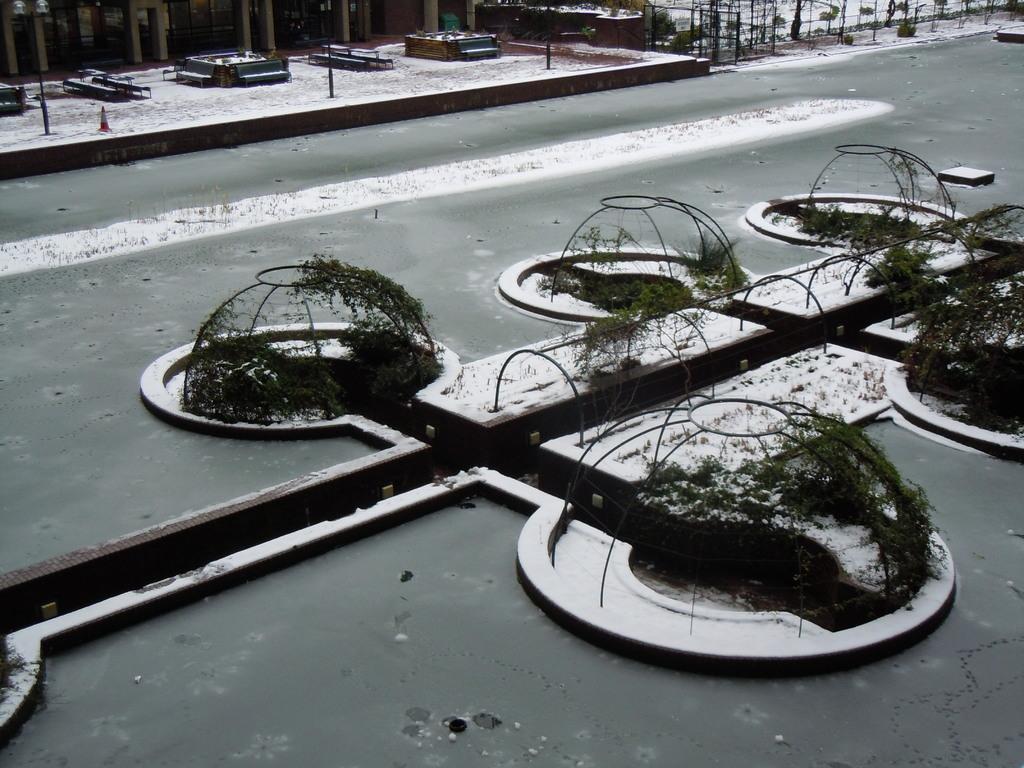Can you describe this image briefly? In this picture we can see some grills here, there are some plants here, there is snow here, we can see metal rods in the background. 